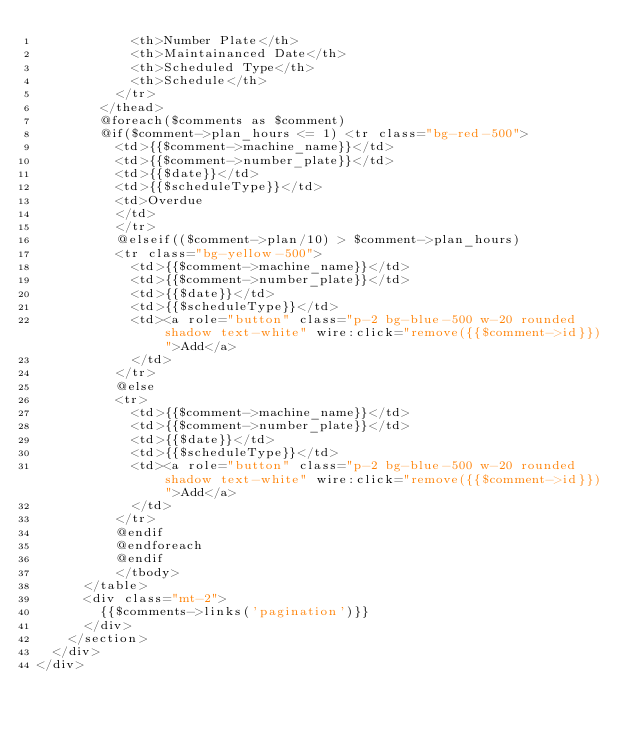<code> <loc_0><loc_0><loc_500><loc_500><_PHP_>            <th>Number Plate</th>
            <th>Maintainanced Date</th>
            <th>Scheduled Type</th>
            <th>Schedule</th>
          </tr>
        </thead>
        @foreach($comments as $comment)
        @if($comment->plan_hours <= 1) <tr class="bg-red-500">
          <td>{{$comment->machine_name}}</td>
          <td>{{$comment->number_plate}}</td>
          <td>{{$date}}</td>
          <td>{{$scheduleType}}</td>
          <td>Overdue
          </td>
          </tr>
          @elseif(($comment->plan/10) > $comment->plan_hours)
          <tr class="bg-yellow-500">
            <td>{{$comment->machine_name}}</td>
            <td>{{$comment->number_plate}}</td>
            <td>{{$date}}</td>
            <td>{{$scheduleType}}</td>
            <td><a role="button" class="p-2 bg-blue-500 w-20 rounded shadow text-white" wire:click="remove({{$comment->id}})">Add</a>
            </td>
          </tr>
          @else
          <tr>
            <td>{{$comment->machine_name}}</td>
            <td>{{$comment->number_plate}}</td>
            <td>{{$date}}</td>
            <td>{{$scheduleType}}</td>
            <td><a role="button" class="p-2 bg-blue-500 w-20 rounded shadow text-white" wire:click="remove({{$comment->id}})">Add</a>
            </td>
          </tr>
          @endif
          @endforeach
          @endif
          </tbody>
      </table>
      <div class="mt-2">
        {{$comments->links('pagination')}}
      </div>
    </section>
  </div>
</div></code> 